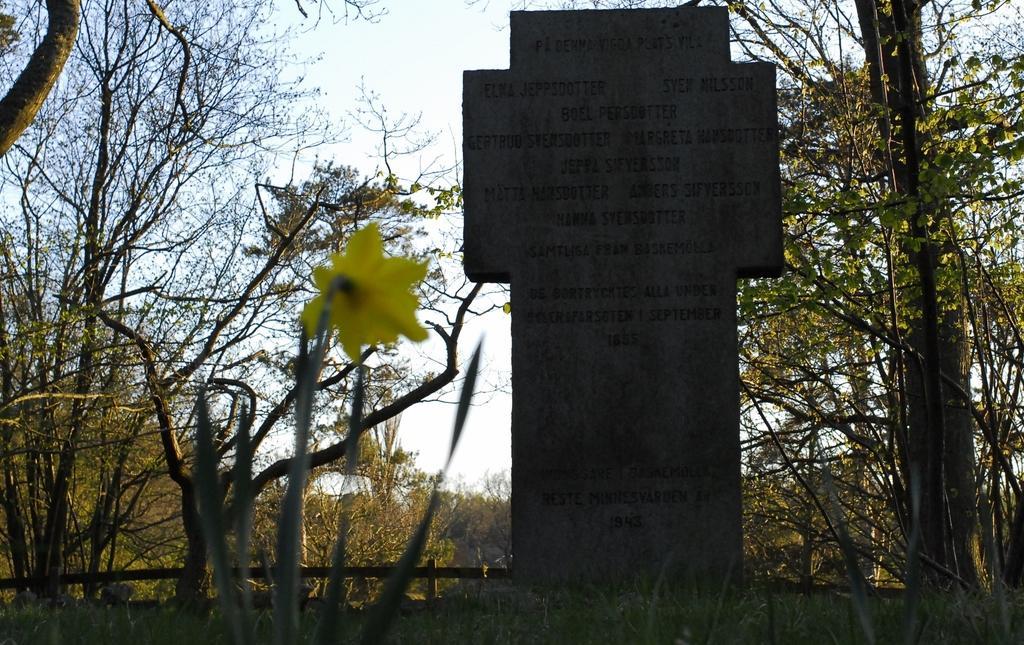Please provide a concise description of this image. In the picture I can see a headstone which has something written on it and there is a fence and few trees in the background. 